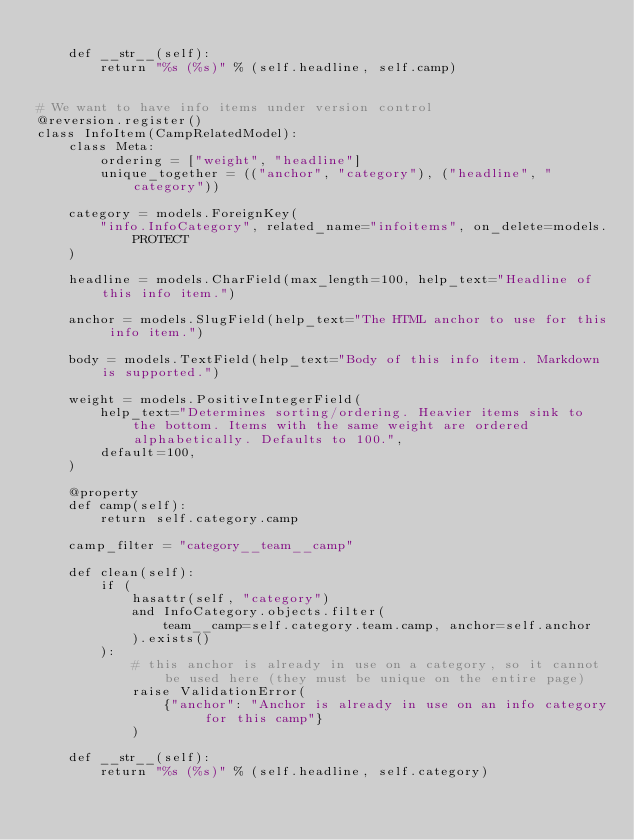<code> <loc_0><loc_0><loc_500><loc_500><_Python_>
    def __str__(self):
        return "%s (%s)" % (self.headline, self.camp)


# We want to have info items under version control
@reversion.register()
class InfoItem(CampRelatedModel):
    class Meta:
        ordering = ["weight", "headline"]
        unique_together = (("anchor", "category"), ("headline", "category"))

    category = models.ForeignKey(
        "info.InfoCategory", related_name="infoitems", on_delete=models.PROTECT
    )

    headline = models.CharField(max_length=100, help_text="Headline of this info item.")

    anchor = models.SlugField(help_text="The HTML anchor to use for this info item.")

    body = models.TextField(help_text="Body of this info item. Markdown is supported.")

    weight = models.PositiveIntegerField(
        help_text="Determines sorting/ordering. Heavier items sink to the bottom. Items with the same weight are ordered alphabetically. Defaults to 100.",
        default=100,
    )

    @property
    def camp(self):
        return self.category.camp

    camp_filter = "category__team__camp"

    def clean(self):
        if (
            hasattr(self, "category")
            and InfoCategory.objects.filter(
                team__camp=self.category.team.camp, anchor=self.anchor
            ).exists()
        ):
            # this anchor is already in use on a category, so it cannot be used here (they must be unique on the entire page)
            raise ValidationError(
                {"anchor": "Anchor is already in use on an info category for this camp"}
            )

    def __str__(self):
        return "%s (%s)" % (self.headline, self.category)
</code> 